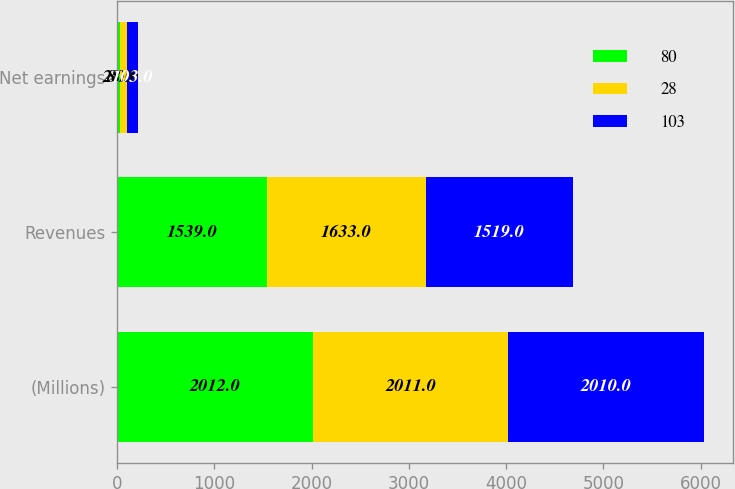Convert chart. <chart><loc_0><loc_0><loc_500><loc_500><stacked_bar_chart><ecel><fcel>(Millions)<fcel>Revenues<fcel>Net earnings<nl><fcel>80<fcel>2012<fcel>1539<fcel>28<nl><fcel>28<fcel>2011<fcel>1633<fcel>80<nl><fcel>103<fcel>2010<fcel>1519<fcel>103<nl></chart> 